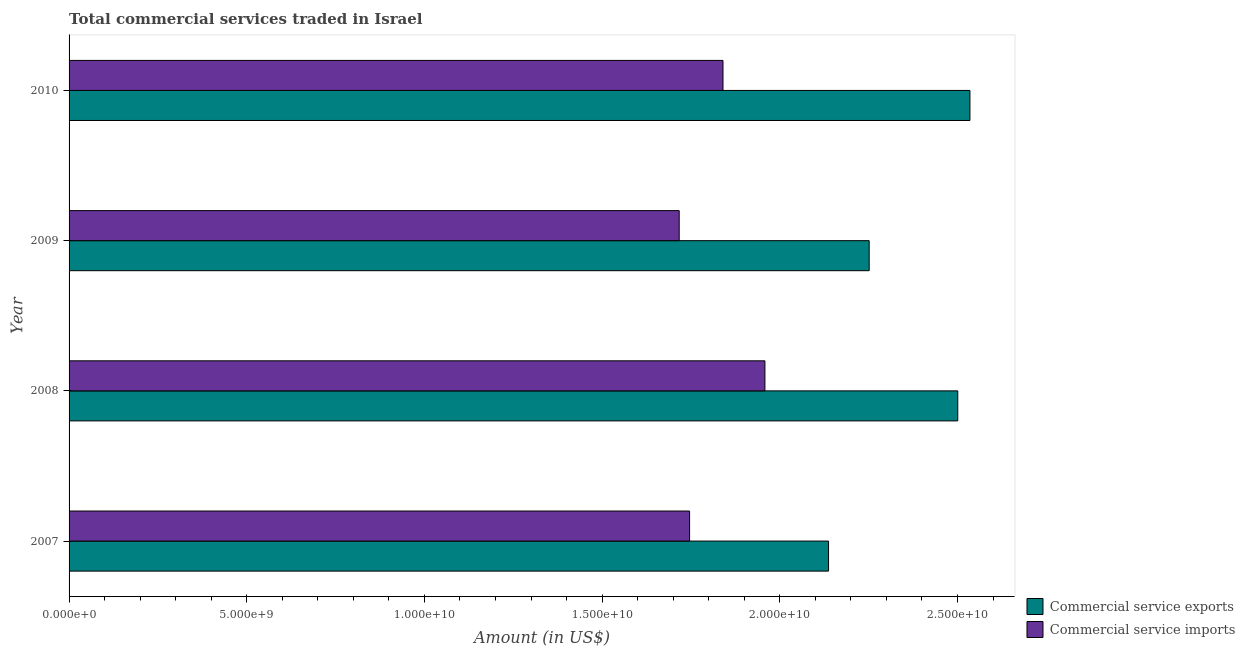How many different coloured bars are there?
Offer a terse response. 2. How many groups of bars are there?
Your answer should be very brief. 4. What is the amount of commercial service imports in 2010?
Ensure brevity in your answer.  1.84e+1. Across all years, what is the maximum amount of commercial service imports?
Make the answer very short. 1.96e+1. Across all years, what is the minimum amount of commercial service exports?
Keep it short and to the point. 2.14e+1. In which year was the amount of commercial service exports minimum?
Offer a terse response. 2007. What is the total amount of commercial service imports in the graph?
Your answer should be very brief. 7.26e+1. What is the difference between the amount of commercial service imports in 2008 and that in 2009?
Ensure brevity in your answer.  2.41e+09. What is the difference between the amount of commercial service exports in 2008 and the amount of commercial service imports in 2007?
Your answer should be compact. 7.55e+09. What is the average amount of commercial service imports per year?
Ensure brevity in your answer.  1.82e+1. In the year 2008, what is the difference between the amount of commercial service imports and amount of commercial service exports?
Give a very brief answer. -5.43e+09. In how many years, is the amount of commercial service imports greater than 16000000000 US$?
Make the answer very short. 4. What is the ratio of the amount of commercial service imports in 2008 to that in 2009?
Your response must be concise. 1.14. Is the amount of commercial service imports in 2008 less than that in 2010?
Keep it short and to the point. No. What is the difference between the highest and the second highest amount of commercial service imports?
Offer a terse response. 1.18e+09. What is the difference between the highest and the lowest amount of commercial service imports?
Provide a short and direct response. 2.41e+09. In how many years, is the amount of commercial service imports greater than the average amount of commercial service imports taken over all years?
Your response must be concise. 2. What does the 2nd bar from the top in 2007 represents?
Ensure brevity in your answer.  Commercial service exports. What does the 1st bar from the bottom in 2010 represents?
Your answer should be compact. Commercial service exports. Are all the bars in the graph horizontal?
Your answer should be very brief. Yes. How many years are there in the graph?
Offer a very short reply. 4. What is the difference between two consecutive major ticks on the X-axis?
Make the answer very short. 5.00e+09. Does the graph contain any zero values?
Give a very brief answer. No. How many legend labels are there?
Provide a succinct answer. 2. How are the legend labels stacked?
Give a very brief answer. Vertical. What is the title of the graph?
Provide a succinct answer. Total commercial services traded in Israel. What is the label or title of the X-axis?
Give a very brief answer. Amount (in US$). What is the Amount (in US$) in Commercial service exports in 2007?
Your response must be concise. 2.14e+1. What is the Amount (in US$) of Commercial service imports in 2007?
Offer a very short reply. 1.75e+1. What is the Amount (in US$) in Commercial service exports in 2008?
Provide a succinct answer. 2.50e+1. What is the Amount (in US$) in Commercial service imports in 2008?
Keep it short and to the point. 1.96e+1. What is the Amount (in US$) in Commercial service exports in 2009?
Offer a very short reply. 2.25e+1. What is the Amount (in US$) in Commercial service imports in 2009?
Provide a short and direct response. 1.72e+1. What is the Amount (in US$) of Commercial service exports in 2010?
Make the answer very short. 2.54e+1. What is the Amount (in US$) of Commercial service imports in 2010?
Keep it short and to the point. 1.84e+1. Across all years, what is the maximum Amount (in US$) in Commercial service exports?
Your response must be concise. 2.54e+1. Across all years, what is the maximum Amount (in US$) in Commercial service imports?
Ensure brevity in your answer.  1.96e+1. Across all years, what is the minimum Amount (in US$) in Commercial service exports?
Keep it short and to the point. 2.14e+1. Across all years, what is the minimum Amount (in US$) in Commercial service imports?
Make the answer very short. 1.72e+1. What is the total Amount (in US$) of Commercial service exports in the graph?
Your answer should be compact. 9.42e+1. What is the total Amount (in US$) of Commercial service imports in the graph?
Your answer should be compact. 7.26e+1. What is the difference between the Amount (in US$) of Commercial service exports in 2007 and that in 2008?
Offer a very short reply. -3.64e+09. What is the difference between the Amount (in US$) in Commercial service imports in 2007 and that in 2008?
Offer a very short reply. -2.12e+09. What is the difference between the Amount (in US$) of Commercial service exports in 2007 and that in 2009?
Provide a short and direct response. -1.14e+09. What is the difference between the Amount (in US$) of Commercial service imports in 2007 and that in 2009?
Make the answer very short. 2.92e+08. What is the difference between the Amount (in US$) in Commercial service exports in 2007 and that in 2010?
Give a very brief answer. -3.98e+09. What is the difference between the Amount (in US$) in Commercial service imports in 2007 and that in 2010?
Give a very brief answer. -9.40e+08. What is the difference between the Amount (in US$) in Commercial service exports in 2008 and that in 2009?
Your response must be concise. 2.49e+09. What is the difference between the Amount (in US$) of Commercial service imports in 2008 and that in 2009?
Keep it short and to the point. 2.41e+09. What is the difference between the Amount (in US$) of Commercial service exports in 2008 and that in 2010?
Offer a very short reply. -3.42e+08. What is the difference between the Amount (in US$) of Commercial service imports in 2008 and that in 2010?
Offer a very short reply. 1.18e+09. What is the difference between the Amount (in US$) of Commercial service exports in 2009 and that in 2010?
Make the answer very short. -2.83e+09. What is the difference between the Amount (in US$) of Commercial service imports in 2009 and that in 2010?
Make the answer very short. -1.23e+09. What is the difference between the Amount (in US$) in Commercial service exports in 2007 and the Amount (in US$) in Commercial service imports in 2008?
Make the answer very short. 1.79e+09. What is the difference between the Amount (in US$) of Commercial service exports in 2007 and the Amount (in US$) of Commercial service imports in 2009?
Provide a short and direct response. 4.20e+09. What is the difference between the Amount (in US$) of Commercial service exports in 2007 and the Amount (in US$) of Commercial service imports in 2010?
Provide a short and direct response. 2.97e+09. What is the difference between the Amount (in US$) of Commercial service exports in 2008 and the Amount (in US$) of Commercial service imports in 2009?
Your answer should be compact. 7.84e+09. What is the difference between the Amount (in US$) in Commercial service exports in 2008 and the Amount (in US$) in Commercial service imports in 2010?
Your answer should be compact. 6.61e+09. What is the difference between the Amount (in US$) of Commercial service exports in 2009 and the Amount (in US$) of Commercial service imports in 2010?
Give a very brief answer. 4.11e+09. What is the average Amount (in US$) in Commercial service exports per year?
Give a very brief answer. 2.36e+1. What is the average Amount (in US$) in Commercial service imports per year?
Your answer should be compact. 1.82e+1. In the year 2007, what is the difference between the Amount (in US$) of Commercial service exports and Amount (in US$) of Commercial service imports?
Keep it short and to the point. 3.91e+09. In the year 2008, what is the difference between the Amount (in US$) in Commercial service exports and Amount (in US$) in Commercial service imports?
Ensure brevity in your answer.  5.43e+09. In the year 2009, what is the difference between the Amount (in US$) in Commercial service exports and Amount (in US$) in Commercial service imports?
Ensure brevity in your answer.  5.35e+09. In the year 2010, what is the difference between the Amount (in US$) of Commercial service exports and Amount (in US$) of Commercial service imports?
Your response must be concise. 6.95e+09. What is the ratio of the Amount (in US$) of Commercial service exports in 2007 to that in 2008?
Provide a short and direct response. 0.85. What is the ratio of the Amount (in US$) of Commercial service imports in 2007 to that in 2008?
Give a very brief answer. 0.89. What is the ratio of the Amount (in US$) in Commercial service exports in 2007 to that in 2009?
Offer a terse response. 0.95. What is the ratio of the Amount (in US$) in Commercial service exports in 2007 to that in 2010?
Make the answer very short. 0.84. What is the ratio of the Amount (in US$) in Commercial service imports in 2007 to that in 2010?
Make the answer very short. 0.95. What is the ratio of the Amount (in US$) in Commercial service exports in 2008 to that in 2009?
Provide a short and direct response. 1.11. What is the ratio of the Amount (in US$) of Commercial service imports in 2008 to that in 2009?
Make the answer very short. 1.14. What is the ratio of the Amount (in US$) of Commercial service exports in 2008 to that in 2010?
Keep it short and to the point. 0.99. What is the ratio of the Amount (in US$) in Commercial service imports in 2008 to that in 2010?
Your response must be concise. 1.06. What is the ratio of the Amount (in US$) of Commercial service exports in 2009 to that in 2010?
Offer a terse response. 0.89. What is the ratio of the Amount (in US$) in Commercial service imports in 2009 to that in 2010?
Offer a very short reply. 0.93. What is the difference between the highest and the second highest Amount (in US$) in Commercial service exports?
Offer a terse response. 3.42e+08. What is the difference between the highest and the second highest Amount (in US$) in Commercial service imports?
Offer a terse response. 1.18e+09. What is the difference between the highest and the lowest Amount (in US$) in Commercial service exports?
Provide a succinct answer. 3.98e+09. What is the difference between the highest and the lowest Amount (in US$) in Commercial service imports?
Offer a very short reply. 2.41e+09. 